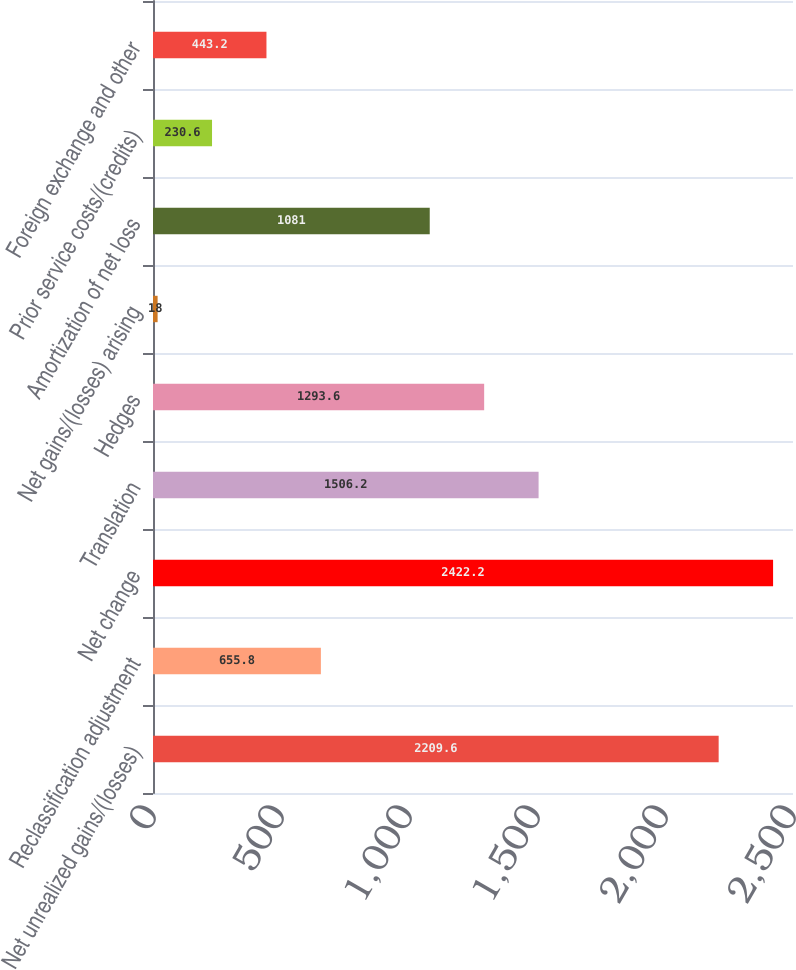Convert chart. <chart><loc_0><loc_0><loc_500><loc_500><bar_chart><fcel>Net unrealized gains/(losses)<fcel>Reclassification adjustment<fcel>Net change<fcel>Translation<fcel>Hedges<fcel>Net gains/(losses) arising<fcel>Amortization of net loss<fcel>Prior service costs/(credits)<fcel>Foreign exchange and other<nl><fcel>2209.6<fcel>655.8<fcel>2422.2<fcel>1506.2<fcel>1293.6<fcel>18<fcel>1081<fcel>230.6<fcel>443.2<nl></chart> 